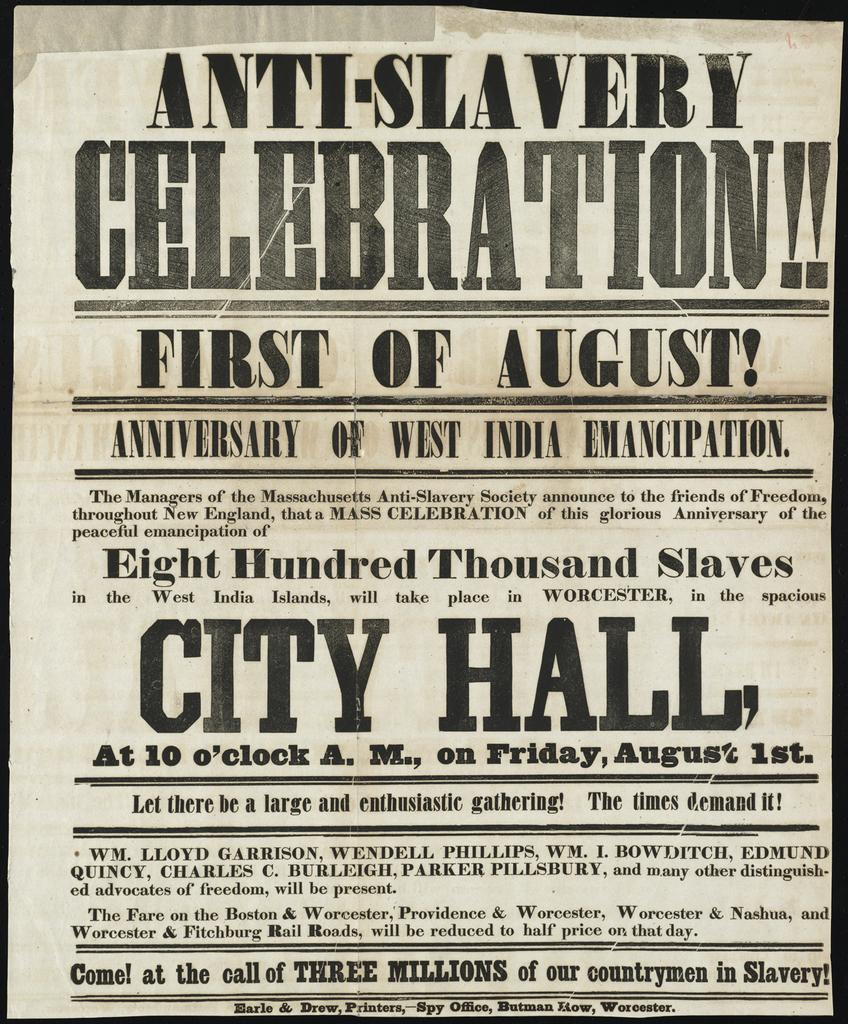<image>
Provide a brief description of the given image. Antique Anti-Slavery City Hall Celebration poster in white and black text. 